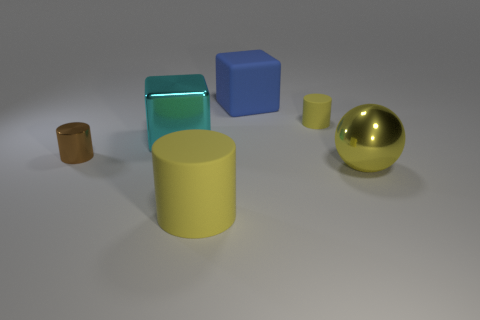Are there any other things that are the same size as the blue object?
Provide a short and direct response. Yes. There is a brown thing that is the same shape as the big yellow matte object; what material is it?
Provide a succinct answer. Metal. Is the number of brown objects greater than the number of small green rubber balls?
Your answer should be compact. Yes. How many other things are the same color as the small matte cylinder?
Offer a terse response. 2. Does the yellow ball have the same material as the cube that is left of the blue cube?
Provide a short and direct response. Yes. There is a cylinder that is on the right side of the big yellow rubber thing in front of the brown thing; how many tiny matte things are on the right side of it?
Give a very brief answer. 0. Is the number of tiny yellow cylinders to the left of the brown metallic object less than the number of cyan metal cubes that are right of the yellow metal sphere?
Ensure brevity in your answer.  No. How many other things are the same material as the large cyan block?
Keep it short and to the point. 2. There is a cylinder that is the same size as the metal cube; what material is it?
Make the answer very short. Rubber. What number of yellow objects are large rubber cylinders or big shiny cubes?
Your answer should be very brief. 1. 